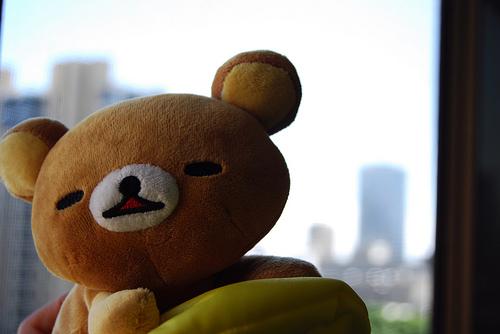What animal is in the picture?
Give a very brief answer. Bear. Is this toy in front of a window?
Quick response, please. Yes. Can you see the bear's mouth?
Answer briefly. Yes. What color is the animal's nose?
Keep it brief. Black. Is this a stuffed animal?
Write a very short answer. Yes. 